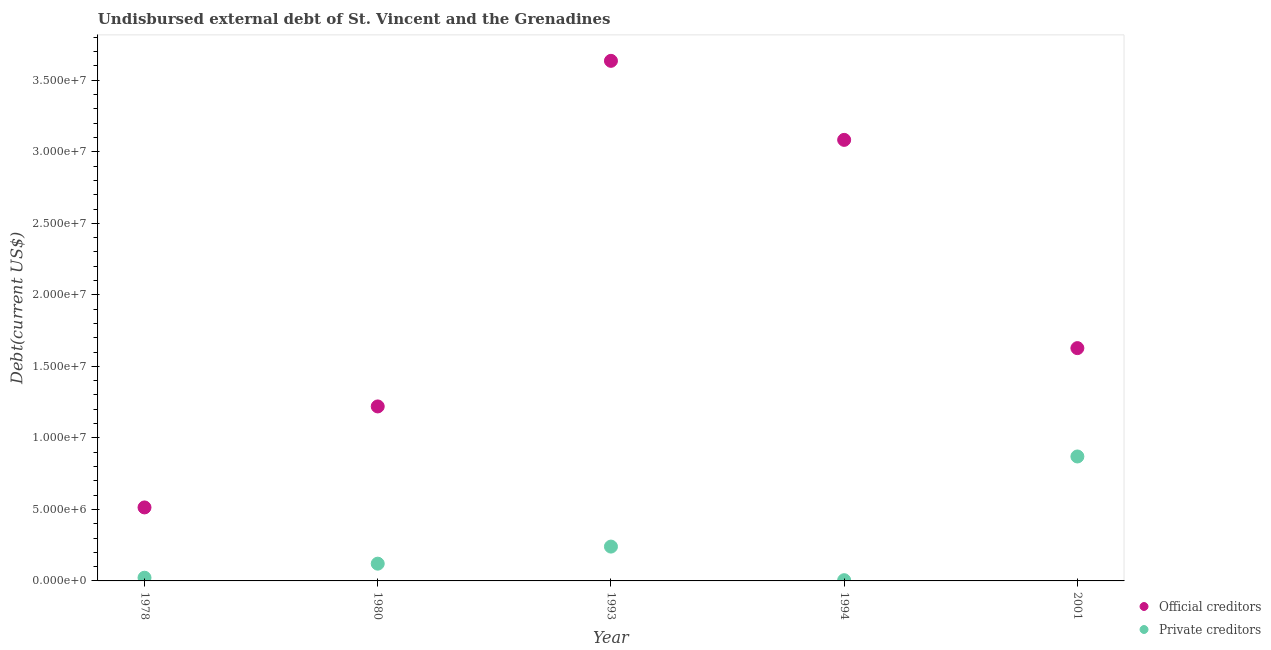What is the undisbursed external debt of private creditors in 1993?
Make the answer very short. 2.40e+06. Across all years, what is the maximum undisbursed external debt of private creditors?
Your answer should be very brief. 8.70e+06. Across all years, what is the minimum undisbursed external debt of official creditors?
Provide a succinct answer. 5.14e+06. In which year was the undisbursed external debt of official creditors minimum?
Ensure brevity in your answer.  1978. What is the total undisbursed external debt of private creditors in the graph?
Make the answer very short. 1.26e+07. What is the difference between the undisbursed external debt of private creditors in 1994 and that in 2001?
Make the answer very short. -8.65e+06. What is the difference between the undisbursed external debt of private creditors in 1994 and the undisbursed external debt of official creditors in 1980?
Keep it short and to the point. -1.21e+07. What is the average undisbursed external debt of private creditors per year?
Keep it short and to the point. 2.52e+06. In the year 1978, what is the difference between the undisbursed external debt of private creditors and undisbursed external debt of official creditors?
Make the answer very short. -4.92e+06. In how many years, is the undisbursed external debt of private creditors greater than 29000000 US$?
Provide a short and direct response. 0. What is the ratio of the undisbursed external debt of private creditors in 1980 to that in 1993?
Provide a short and direct response. 0.5. Is the difference between the undisbursed external debt of official creditors in 1978 and 1980 greater than the difference between the undisbursed external debt of private creditors in 1978 and 1980?
Ensure brevity in your answer.  No. What is the difference between the highest and the second highest undisbursed external debt of official creditors?
Provide a short and direct response. 5.52e+06. What is the difference between the highest and the lowest undisbursed external debt of private creditors?
Provide a succinct answer. 8.65e+06. In how many years, is the undisbursed external debt of official creditors greater than the average undisbursed external debt of official creditors taken over all years?
Provide a short and direct response. 2. Is the sum of the undisbursed external debt of private creditors in 1993 and 2001 greater than the maximum undisbursed external debt of official creditors across all years?
Give a very brief answer. No. How many years are there in the graph?
Your answer should be compact. 5. What is the difference between two consecutive major ticks on the Y-axis?
Offer a very short reply. 5.00e+06. Are the values on the major ticks of Y-axis written in scientific E-notation?
Provide a short and direct response. Yes. Does the graph contain any zero values?
Give a very brief answer. No. How many legend labels are there?
Your answer should be very brief. 2. How are the legend labels stacked?
Make the answer very short. Vertical. What is the title of the graph?
Offer a very short reply. Undisbursed external debt of St. Vincent and the Grenadines. Does "Netherlands" appear as one of the legend labels in the graph?
Your response must be concise. No. What is the label or title of the X-axis?
Make the answer very short. Year. What is the label or title of the Y-axis?
Your answer should be compact. Debt(current US$). What is the Debt(current US$) of Official creditors in 1978?
Keep it short and to the point. 5.14e+06. What is the Debt(current US$) in Private creditors in 1978?
Provide a succinct answer. 2.23e+05. What is the Debt(current US$) of Official creditors in 1980?
Make the answer very short. 1.22e+07. What is the Debt(current US$) of Private creditors in 1980?
Offer a very short reply. 1.21e+06. What is the Debt(current US$) of Official creditors in 1993?
Offer a terse response. 3.64e+07. What is the Debt(current US$) in Private creditors in 1993?
Your answer should be compact. 2.40e+06. What is the Debt(current US$) of Official creditors in 1994?
Your answer should be compact. 3.08e+07. What is the Debt(current US$) in Private creditors in 1994?
Offer a very short reply. 5.10e+04. What is the Debt(current US$) in Official creditors in 2001?
Make the answer very short. 1.63e+07. What is the Debt(current US$) in Private creditors in 2001?
Make the answer very short. 8.70e+06. Across all years, what is the maximum Debt(current US$) of Official creditors?
Your answer should be compact. 3.64e+07. Across all years, what is the maximum Debt(current US$) of Private creditors?
Your answer should be very brief. 8.70e+06. Across all years, what is the minimum Debt(current US$) in Official creditors?
Keep it short and to the point. 5.14e+06. Across all years, what is the minimum Debt(current US$) in Private creditors?
Offer a terse response. 5.10e+04. What is the total Debt(current US$) of Official creditors in the graph?
Offer a terse response. 1.01e+08. What is the total Debt(current US$) in Private creditors in the graph?
Provide a short and direct response. 1.26e+07. What is the difference between the Debt(current US$) in Official creditors in 1978 and that in 1980?
Your answer should be compact. -7.06e+06. What is the difference between the Debt(current US$) in Private creditors in 1978 and that in 1980?
Provide a succinct answer. -9.84e+05. What is the difference between the Debt(current US$) of Official creditors in 1978 and that in 1993?
Provide a succinct answer. -3.12e+07. What is the difference between the Debt(current US$) of Private creditors in 1978 and that in 1993?
Keep it short and to the point. -2.18e+06. What is the difference between the Debt(current US$) in Official creditors in 1978 and that in 1994?
Offer a terse response. -2.57e+07. What is the difference between the Debt(current US$) of Private creditors in 1978 and that in 1994?
Make the answer very short. 1.72e+05. What is the difference between the Debt(current US$) of Official creditors in 1978 and that in 2001?
Your answer should be compact. -1.11e+07. What is the difference between the Debt(current US$) in Private creditors in 1978 and that in 2001?
Give a very brief answer. -8.48e+06. What is the difference between the Debt(current US$) in Official creditors in 1980 and that in 1993?
Ensure brevity in your answer.  -2.42e+07. What is the difference between the Debt(current US$) of Private creditors in 1980 and that in 1993?
Offer a terse response. -1.19e+06. What is the difference between the Debt(current US$) in Official creditors in 1980 and that in 1994?
Your answer should be very brief. -1.86e+07. What is the difference between the Debt(current US$) of Private creditors in 1980 and that in 1994?
Your answer should be compact. 1.16e+06. What is the difference between the Debt(current US$) in Official creditors in 1980 and that in 2001?
Provide a succinct answer. -4.08e+06. What is the difference between the Debt(current US$) in Private creditors in 1980 and that in 2001?
Provide a succinct answer. -7.49e+06. What is the difference between the Debt(current US$) of Official creditors in 1993 and that in 1994?
Your answer should be compact. 5.52e+06. What is the difference between the Debt(current US$) in Private creditors in 1993 and that in 1994?
Keep it short and to the point. 2.35e+06. What is the difference between the Debt(current US$) in Official creditors in 1993 and that in 2001?
Ensure brevity in your answer.  2.01e+07. What is the difference between the Debt(current US$) of Private creditors in 1993 and that in 2001?
Keep it short and to the point. -6.30e+06. What is the difference between the Debt(current US$) of Official creditors in 1994 and that in 2001?
Give a very brief answer. 1.46e+07. What is the difference between the Debt(current US$) of Private creditors in 1994 and that in 2001?
Ensure brevity in your answer.  -8.65e+06. What is the difference between the Debt(current US$) in Official creditors in 1978 and the Debt(current US$) in Private creditors in 1980?
Your answer should be very brief. 3.93e+06. What is the difference between the Debt(current US$) in Official creditors in 1978 and the Debt(current US$) in Private creditors in 1993?
Provide a succinct answer. 2.74e+06. What is the difference between the Debt(current US$) of Official creditors in 1978 and the Debt(current US$) of Private creditors in 1994?
Provide a succinct answer. 5.09e+06. What is the difference between the Debt(current US$) in Official creditors in 1978 and the Debt(current US$) in Private creditors in 2001?
Keep it short and to the point. -3.56e+06. What is the difference between the Debt(current US$) of Official creditors in 1980 and the Debt(current US$) of Private creditors in 1993?
Make the answer very short. 9.80e+06. What is the difference between the Debt(current US$) in Official creditors in 1980 and the Debt(current US$) in Private creditors in 1994?
Your answer should be compact. 1.21e+07. What is the difference between the Debt(current US$) of Official creditors in 1980 and the Debt(current US$) of Private creditors in 2001?
Make the answer very short. 3.50e+06. What is the difference between the Debt(current US$) in Official creditors in 1993 and the Debt(current US$) in Private creditors in 1994?
Provide a short and direct response. 3.63e+07. What is the difference between the Debt(current US$) of Official creditors in 1993 and the Debt(current US$) of Private creditors in 2001?
Your answer should be compact. 2.77e+07. What is the difference between the Debt(current US$) in Official creditors in 1994 and the Debt(current US$) in Private creditors in 2001?
Give a very brief answer. 2.21e+07. What is the average Debt(current US$) in Official creditors per year?
Make the answer very short. 2.02e+07. What is the average Debt(current US$) of Private creditors per year?
Your answer should be compact. 2.52e+06. In the year 1978, what is the difference between the Debt(current US$) of Official creditors and Debt(current US$) of Private creditors?
Provide a succinct answer. 4.92e+06. In the year 1980, what is the difference between the Debt(current US$) in Official creditors and Debt(current US$) in Private creditors?
Ensure brevity in your answer.  1.10e+07. In the year 1993, what is the difference between the Debt(current US$) of Official creditors and Debt(current US$) of Private creditors?
Provide a short and direct response. 3.40e+07. In the year 1994, what is the difference between the Debt(current US$) in Official creditors and Debt(current US$) in Private creditors?
Offer a terse response. 3.08e+07. In the year 2001, what is the difference between the Debt(current US$) of Official creditors and Debt(current US$) of Private creditors?
Provide a succinct answer. 7.58e+06. What is the ratio of the Debt(current US$) in Official creditors in 1978 to that in 1980?
Give a very brief answer. 0.42. What is the ratio of the Debt(current US$) in Private creditors in 1978 to that in 1980?
Provide a short and direct response. 0.18. What is the ratio of the Debt(current US$) in Official creditors in 1978 to that in 1993?
Ensure brevity in your answer.  0.14. What is the ratio of the Debt(current US$) in Private creditors in 1978 to that in 1993?
Offer a very short reply. 0.09. What is the ratio of the Debt(current US$) in Official creditors in 1978 to that in 1994?
Offer a terse response. 0.17. What is the ratio of the Debt(current US$) of Private creditors in 1978 to that in 1994?
Offer a terse response. 4.37. What is the ratio of the Debt(current US$) of Official creditors in 1978 to that in 2001?
Ensure brevity in your answer.  0.32. What is the ratio of the Debt(current US$) in Private creditors in 1978 to that in 2001?
Your response must be concise. 0.03. What is the ratio of the Debt(current US$) of Official creditors in 1980 to that in 1993?
Your answer should be compact. 0.34. What is the ratio of the Debt(current US$) in Private creditors in 1980 to that in 1993?
Your answer should be compact. 0.5. What is the ratio of the Debt(current US$) in Official creditors in 1980 to that in 1994?
Your answer should be very brief. 0.4. What is the ratio of the Debt(current US$) of Private creditors in 1980 to that in 1994?
Keep it short and to the point. 23.67. What is the ratio of the Debt(current US$) of Official creditors in 1980 to that in 2001?
Your answer should be very brief. 0.75. What is the ratio of the Debt(current US$) of Private creditors in 1980 to that in 2001?
Make the answer very short. 0.14. What is the ratio of the Debt(current US$) of Official creditors in 1993 to that in 1994?
Offer a very short reply. 1.18. What is the ratio of the Debt(current US$) in Private creditors in 1993 to that in 1994?
Provide a short and direct response. 47.06. What is the ratio of the Debt(current US$) in Official creditors in 1993 to that in 2001?
Your answer should be very brief. 2.23. What is the ratio of the Debt(current US$) of Private creditors in 1993 to that in 2001?
Offer a terse response. 0.28. What is the ratio of the Debt(current US$) of Official creditors in 1994 to that in 2001?
Your answer should be compact. 1.89. What is the ratio of the Debt(current US$) of Private creditors in 1994 to that in 2001?
Provide a succinct answer. 0.01. What is the difference between the highest and the second highest Debt(current US$) in Official creditors?
Make the answer very short. 5.52e+06. What is the difference between the highest and the second highest Debt(current US$) in Private creditors?
Provide a short and direct response. 6.30e+06. What is the difference between the highest and the lowest Debt(current US$) of Official creditors?
Provide a succinct answer. 3.12e+07. What is the difference between the highest and the lowest Debt(current US$) of Private creditors?
Offer a very short reply. 8.65e+06. 